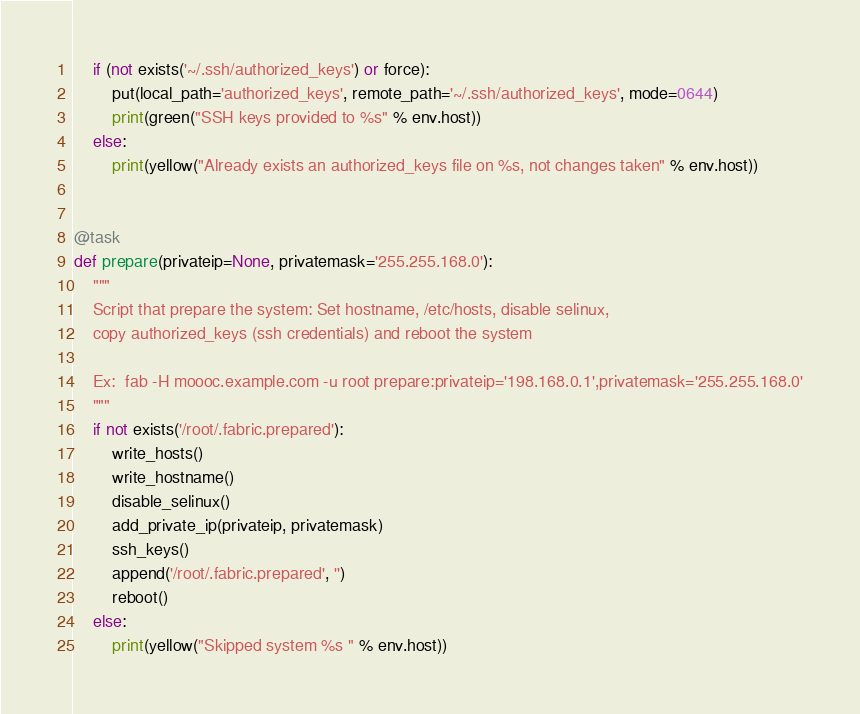<code> <loc_0><loc_0><loc_500><loc_500><_Python_>    if (not exists('~/.ssh/authorized_keys') or force):
        put(local_path='authorized_keys', remote_path='~/.ssh/authorized_keys', mode=0644)
        print(green("SSH keys provided to %s" % env.host))
    else:
        print(yellow("Already exists an authorized_keys file on %s, not changes taken" % env.host))


@task
def prepare(privateip=None, privatemask='255.255.168.0'):
    """
    Script that prepare the system: Set hostname, /etc/hosts, disable selinux,
    copy authorized_keys (ssh credentials) and reboot the system

    Ex:  fab -H moooc.example.com -u root prepare:privateip='198.168.0.1',privatemask='255.255.168.0'
    """
    if not exists('/root/.fabric.prepared'):
        write_hosts()
        write_hostname()
        disable_selinux()
        add_private_ip(privateip, privatemask)
        ssh_keys()
        append('/root/.fabric.prepared', '')
        reboot()
    else:
        print(yellow("Skipped system %s " % env.host))
</code> 